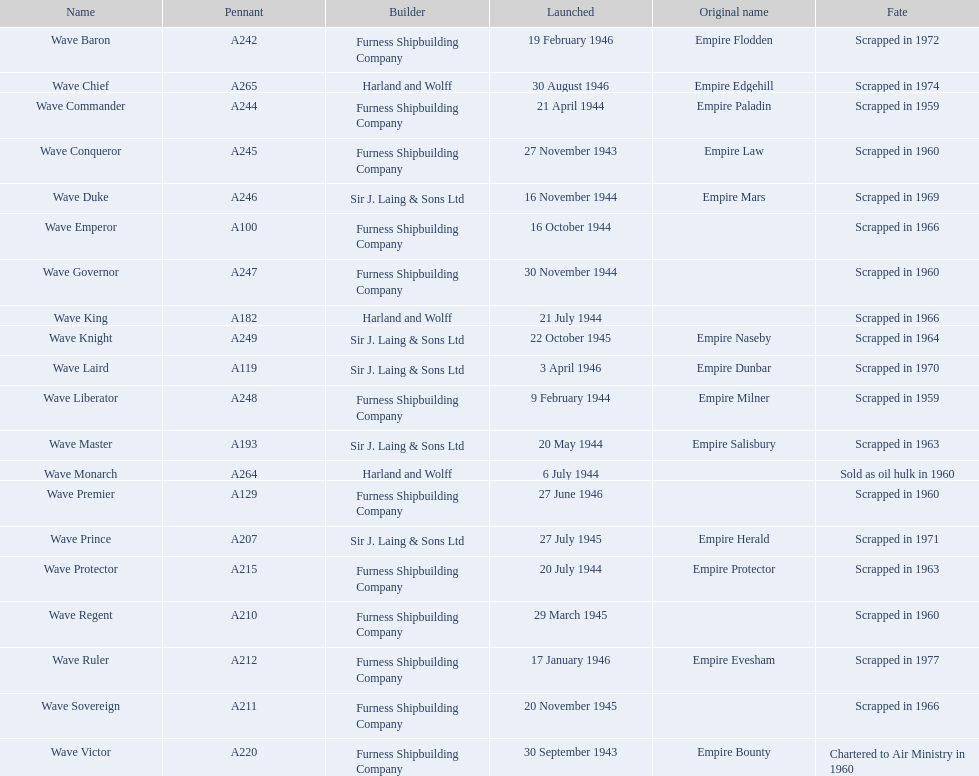In which year was the wave victor introduced? 30 September 1943. Which additional vessel was launched in 1943? Wave Conqueror. 